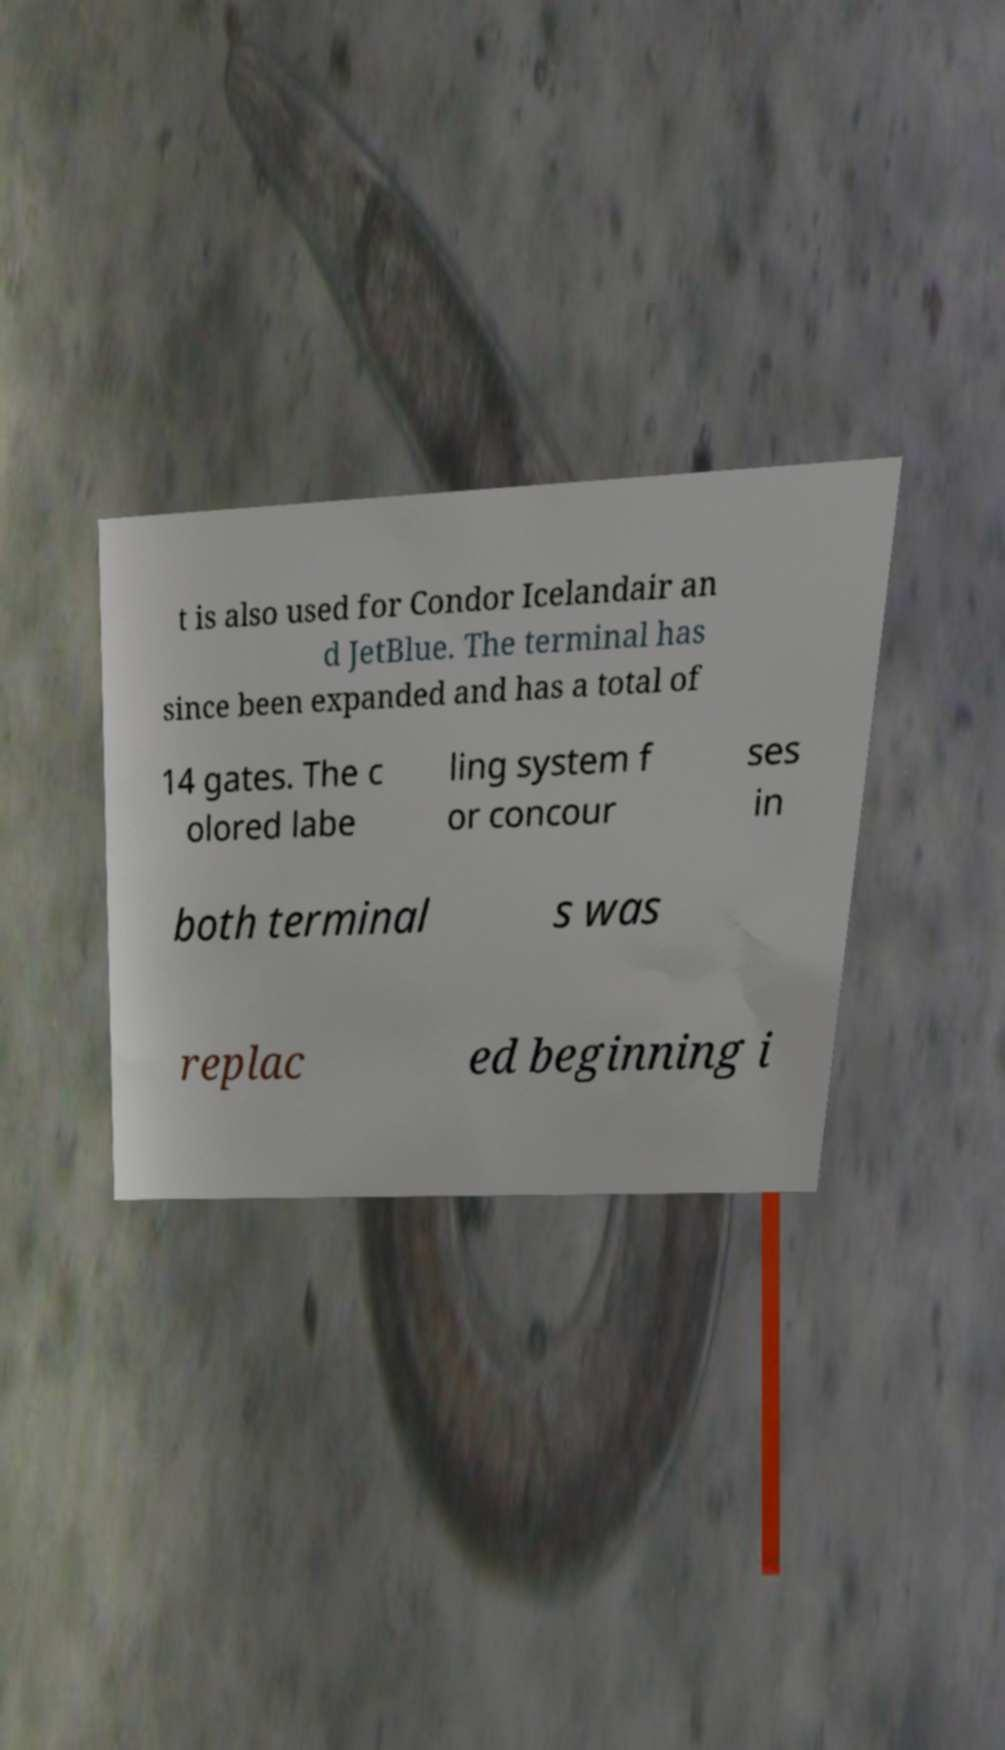Can you accurately transcribe the text from the provided image for me? t is also used for Condor Icelandair an d JetBlue. The terminal has since been expanded and has a total of 14 gates. The c olored labe ling system f or concour ses in both terminal s was replac ed beginning i 